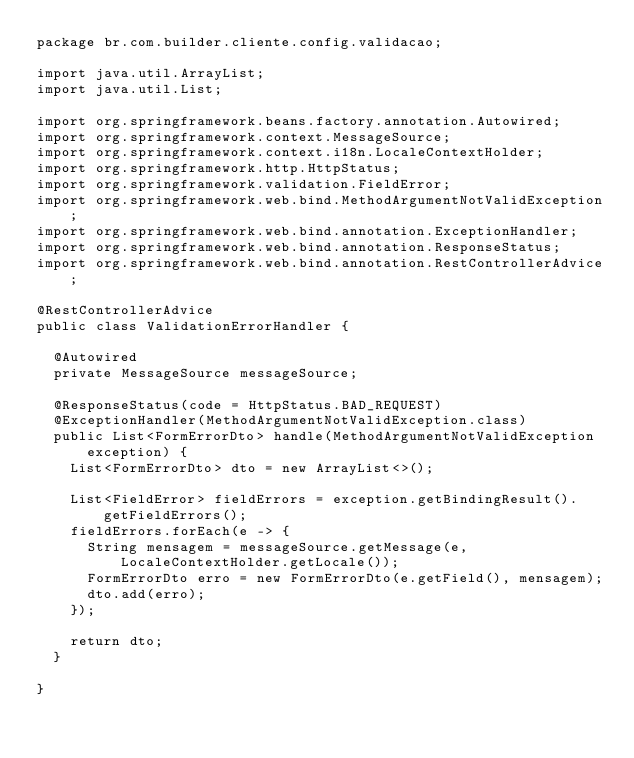Convert code to text. <code><loc_0><loc_0><loc_500><loc_500><_Java_>package br.com.builder.cliente.config.validacao;

import java.util.ArrayList;
import java.util.List;

import org.springframework.beans.factory.annotation.Autowired;
import org.springframework.context.MessageSource;
import org.springframework.context.i18n.LocaleContextHolder;
import org.springframework.http.HttpStatus;
import org.springframework.validation.FieldError;
import org.springframework.web.bind.MethodArgumentNotValidException;
import org.springframework.web.bind.annotation.ExceptionHandler;
import org.springframework.web.bind.annotation.ResponseStatus;
import org.springframework.web.bind.annotation.RestControllerAdvice;

@RestControllerAdvice
public class ValidationErrorHandler {
	
	@Autowired
	private MessageSource messageSource;
	
	@ResponseStatus(code = HttpStatus.BAD_REQUEST)
	@ExceptionHandler(MethodArgumentNotValidException.class)
	public List<FormErrorDto> handle(MethodArgumentNotValidException exception) {
		List<FormErrorDto> dto = new ArrayList<>();
		
		List<FieldError> fieldErrors = exception.getBindingResult().getFieldErrors();
		fieldErrors.forEach(e -> {
			String mensagem = messageSource.getMessage(e, LocaleContextHolder.getLocale());
			FormErrorDto erro = new FormErrorDto(e.getField(), mensagem);
			dto.add(erro);
		});
		
		return dto;
	}

}
</code> 